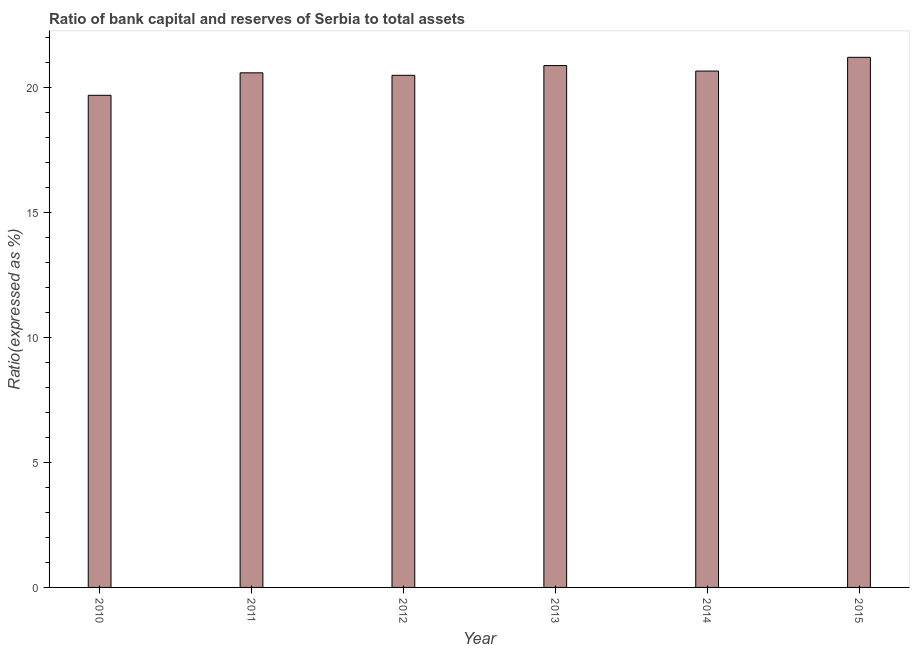Does the graph contain any zero values?
Ensure brevity in your answer.  No. What is the title of the graph?
Your answer should be compact. Ratio of bank capital and reserves of Serbia to total assets. What is the label or title of the X-axis?
Your answer should be compact. Year. What is the label or title of the Y-axis?
Your response must be concise. Ratio(expressed as %). What is the bank capital to assets ratio in 2014?
Your answer should be very brief. 20.67. Across all years, what is the maximum bank capital to assets ratio?
Your answer should be very brief. 21.22. Across all years, what is the minimum bank capital to assets ratio?
Keep it short and to the point. 19.7. In which year was the bank capital to assets ratio maximum?
Your answer should be compact. 2015. What is the sum of the bank capital to assets ratio?
Give a very brief answer. 123.58. What is the difference between the bank capital to assets ratio in 2010 and 2014?
Your response must be concise. -0.97. What is the average bank capital to assets ratio per year?
Offer a very short reply. 20.6. What is the median bank capital to assets ratio?
Your answer should be very brief. 20.64. In how many years, is the bank capital to assets ratio greater than 4 %?
Offer a terse response. 6. Do a majority of the years between 2010 and 2012 (inclusive) have bank capital to assets ratio greater than 8 %?
Keep it short and to the point. Yes. Is the bank capital to assets ratio in 2012 less than that in 2015?
Ensure brevity in your answer.  Yes. Is the difference between the bank capital to assets ratio in 2011 and 2014 greater than the difference between any two years?
Your response must be concise. No. What is the difference between the highest and the second highest bank capital to assets ratio?
Give a very brief answer. 0.33. Is the sum of the bank capital to assets ratio in 2011 and 2015 greater than the maximum bank capital to assets ratio across all years?
Provide a succinct answer. Yes. What is the difference between the highest and the lowest bank capital to assets ratio?
Your answer should be very brief. 1.52. Are all the bars in the graph horizontal?
Make the answer very short. No. What is the Ratio(expressed as %) of 2011?
Ensure brevity in your answer.  20.6. What is the Ratio(expressed as %) in 2012?
Give a very brief answer. 20.5. What is the Ratio(expressed as %) in 2013?
Your response must be concise. 20.89. What is the Ratio(expressed as %) in 2014?
Provide a short and direct response. 20.67. What is the Ratio(expressed as %) in 2015?
Provide a short and direct response. 21.22. What is the difference between the Ratio(expressed as %) in 2010 and 2012?
Keep it short and to the point. -0.8. What is the difference between the Ratio(expressed as %) in 2010 and 2013?
Give a very brief answer. -1.19. What is the difference between the Ratio(expressed as %) in 2010 and 2014?
Offer a very short reply. -0.97. What is the difference between the Ratio(expressed as %) in 2010 and 2015?
Your answer should be very brief. -1.52. What is the difference between the Ratio(expressed as %) in 2011 and 2013?
Keep it short and to the point. -0.29. What is the difference between the Ratio(expressed as %) in 2011 and 2014?
Ensure brevity in your answer.  -0.07. What is the difference between the Ratio(expressed as %) in 2011 and 2015?
Give a very brief answer. -0.62. What is the difference between the Ratio(expressed as %) in 2012 and 2013?
Your response must be concise. -0.39. What is the difference between the Ratio(expressed as %) in 2012 and 2014?
Your answer should be compact. -0.17. What is the difference between the Ratio(expressed as %) in 2012 and 2015?
Offer a very short reply. -0.72. What is the difference between the Ratio(expressed as %) in 2013 and 2014?
Offer a terse response. 0.22. What is the difference between the Ratio(expressed as %) in 2013 and 2015?
Your response must be concise. -0.33. What is the difference between the Ratio(expressed as %) in 2014 and 2015?
Offer a very short reply. -0.55. What is the ratio of the Ratio(expressed as %) in 2010 to that in 2011?
Ensure brevity in your answer.  0.96. What is the ratio of the Ratio(expressed as %) in 2010 to that in 2013?
Offer a very short reply. 0.94. What is the ratio of the Ratio(expressed as %) in 2010 to that in 2014?
Give a very brief answer. 0.95. What is the ratio of the Ratio(expressed as %) in 2010 to that in 2015?
Your answer should be compact. 0.93. What is the ratio of the Ratio(expressed as %) in 2011 to that in 2013?
Provide a short and direct response. 0.99. What is the ratio of the Ratio(expressed as %) in 2011 to that in 2015?
Ensure brevity in your answer.  0.97. What is the ratio of the Ratio(expressed as %) in 2013 to that in 2014?
Offer a very short reply. 1.01. What is the ratio of the Ratio(expressed as %) in 2013 to that in 2015?
Keep it short and to the point. 0.98. 